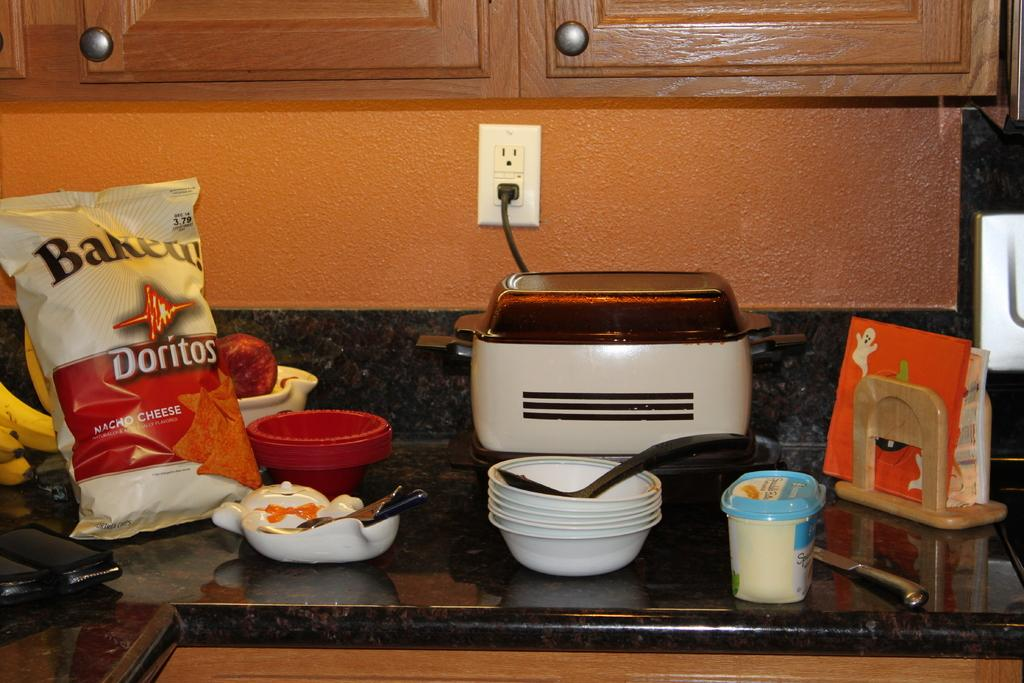<image>
Summarize the visual content of the image. A kitchen counter top covered in bowls, napkins, and a bag of Baked Doritos. 